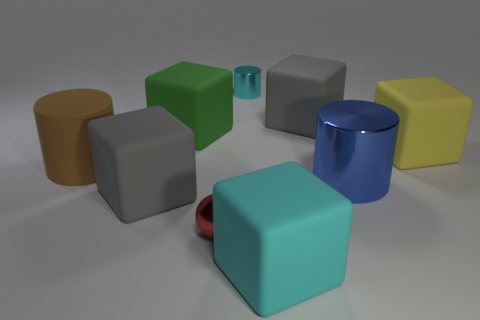What is the dominant color in the image? The dominant colors in the image are shades of grey and blue. The various objects have different colors such as cyan, blue, yellow, and grey, with no single color overwhelming the others in terms of presence. 